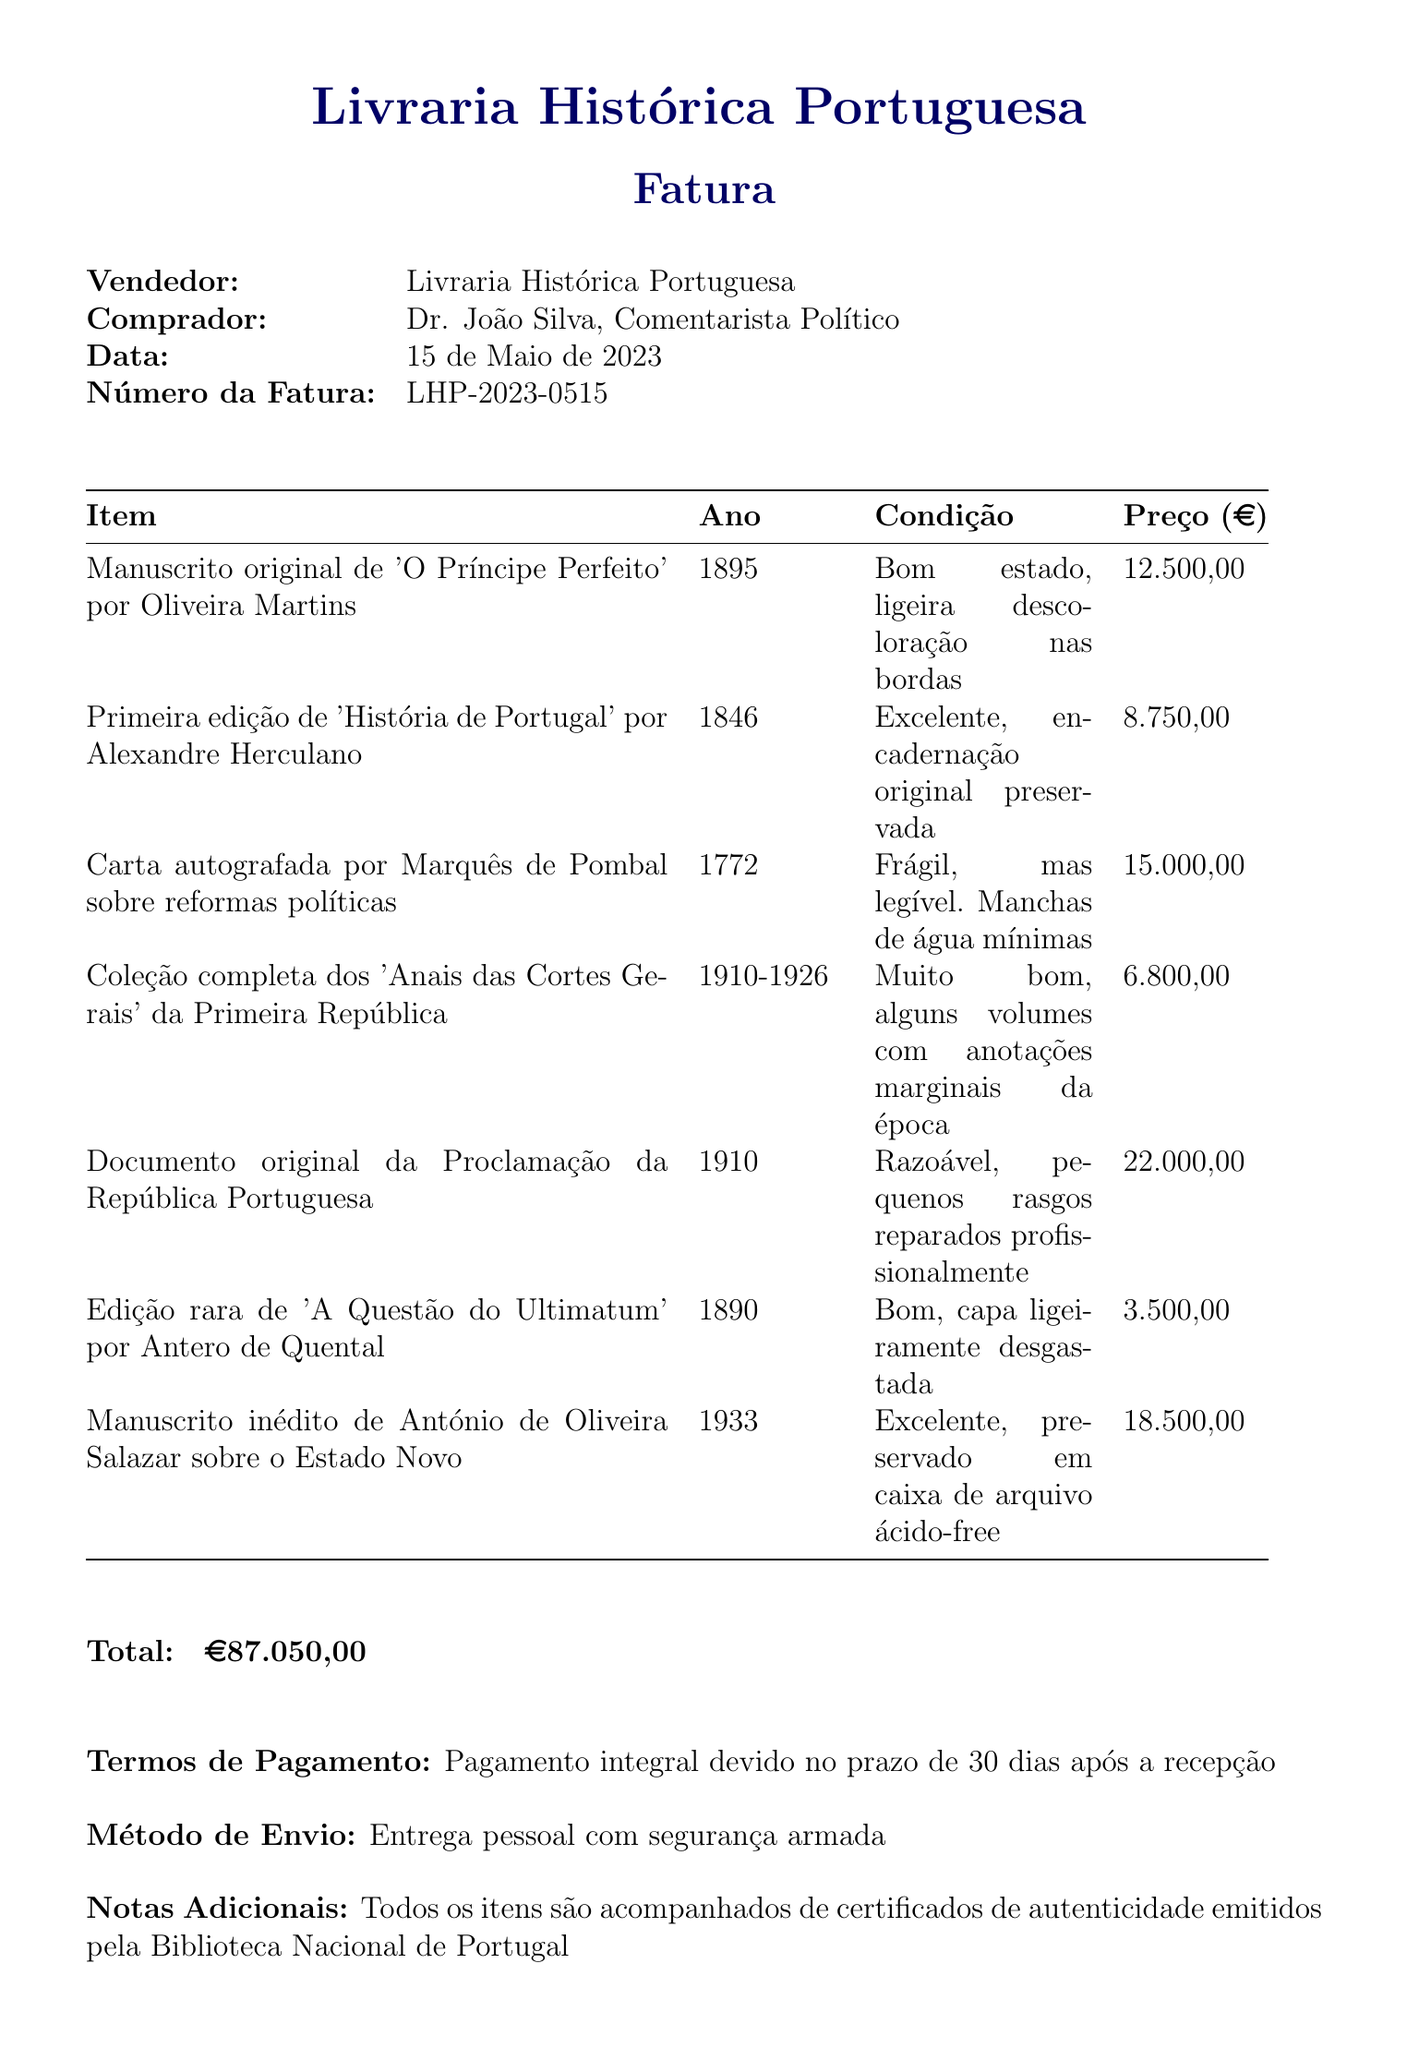what is the seller's name? The seller's name is listed at the top of the document as the entity providing the invoice.
Answer: Livraria Histórica Portuguesa what is the total amount on the invoice? The total amount is shown clearly at the bottom of the document as the final price for all items purchased.
Answer: €87.050,00 when was the invoice issued? The date of the invoice is mentioned in the document and indicates the day it was created.
Answer: 15 de Maio de 2023 how many items are listed in the invoice? The total number of items is reflected in the detailed list provided in the document.
Answer: 7 what is the condition of the 'Documento original da Proclamação da República Portuguesa'? The condition describes the physical state of the item as mentioned in the document.
Answer: Razoável, pequenos rasgos reparados profissionalmente what is the payment term specified? The payment terms are outlined in the document and indicate when payment is due.
Answer: Pagamento integral devido no prazo de 30 dias após a recepção which item has the highest price? The highest price is indicated next to the item's title in the invoice.
Answer: Documento original da Proclamação da República Portuguesa what is the shipping method stated? The shipping method describes how the purchased items will be delivered, as mentioned in the document.
Answer: Entrega pessoal com segurança armada what year was the 'Primeira edição de História de Portugal' published? The year of publication is provided in parentheses next to the title of the item.
Answer: 1846 